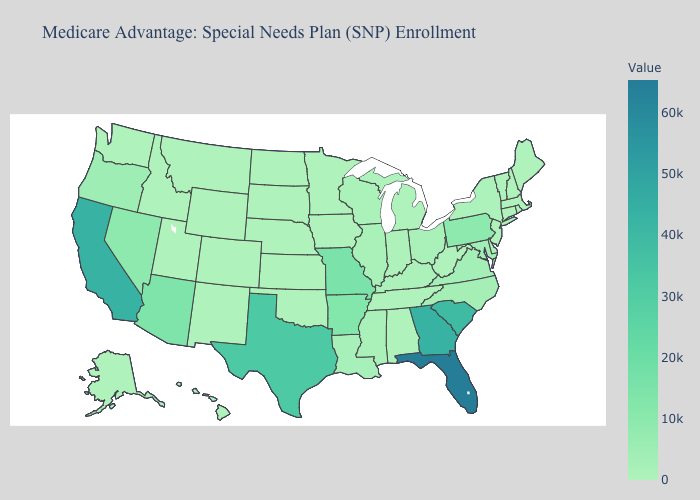Is the legend a continuous bar?
Keep it brief. Yes. Does New Hampshire have the lowest value in the Northeast?
Write a very short answer. Yes. Does Texas have a lower value than Florida?
Write a very short answer. Yes. Which states hav the highest value in the West?
Quick response, please. California. 